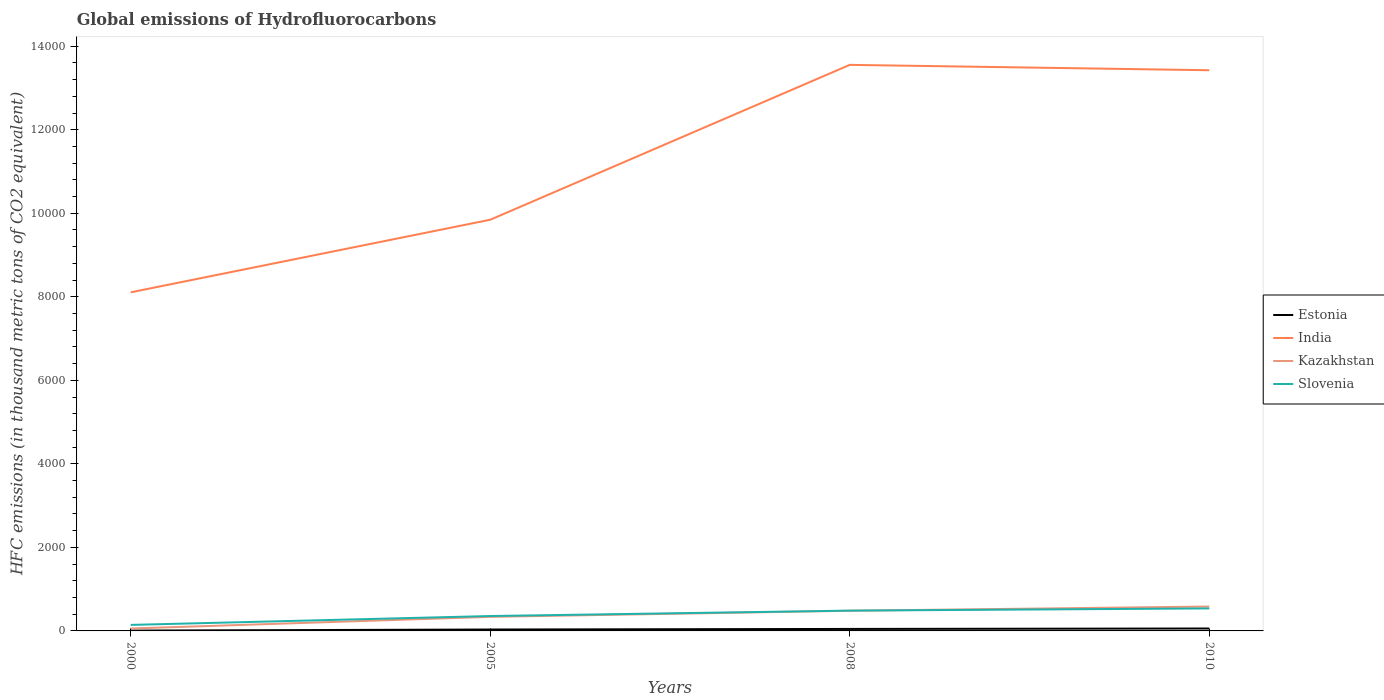How many different coloured lines are there?
Provide a succinct answer. 4. Is the number of lines equal to the number of legend labels?
Keep it short and to the point. Yes. Across all years, what is the maximum global emissions of Hydrofluorocarbons in Kazakhstan?
Keep it short and to the point. 57.5. What is the total global emissions of Hydrofluorocarbons in Kazakhstan in the graph?
Your answer should be very brief. -425.4. What is the difference between the highest and the second highest global emissions of Hydrofluorocarbons in Kazakhstan?
Make the answer very short. 526.5. Is the global emissions of Hydrofluorocarbons in India strictly greater than the global emissions of Hydrofluorocarbons in Estonia over the years?
Offer a very short reply. No. How many lines are there?
Offer a very short reply. 4. What is the difference between two consecutive major ticks on the Y-axis?
Your response must be concise. 2000. Where does the legend appear in the graph?
Give a very brief answer. Center right. How many legend labels are there?
Give a very brief answer. 4. How are the legend labels stacked?
Your answer should be very brief. Vertical. What is the title of the graph?
Keep it short and to the point. Global emissions of Hydrofluorocarbons. What is the label or title of the X-axis?
Your answer should be very brief. Years. What is the label or title of the Y-axis?
Offer a very short reply. HFC emissions (in thousand metric tons of CO2 equivalent). What is the HFC emissions (in thousand metric tons of CO2 equivalent) in India in 2000?
Make the answer very short. 8107.2. What is the HFC emissions (in thousand metric tons of CO2 equivalent) of Kazakhstan in 2000?
Make the answer very short. 57.5. What is the HFC emissions (in thousand metric tons of CO2 equivalent) in Slovenia in 2000?
Keep it short and to the point. 144.1. What is the HFC emissions (in thousand metric tons of CO2 equivalent) in Estonia in 2005?
Make the answer very short. 33.8. What is the HFC emissions (in thousand metric tons of CO2 equivalent) of India in 2005?
Provide a succinct answer. 9845.2. What is the HFC emissions (in thousand metric tons of CO2 equivalent) of Kazakhstan in 2005?
Your answer should be very brief. 336.7. What is the HFC emissions (in thousand metric tons of CO2 equivalent) of Slovenia in 2005?
Keep it short and to the point. 356.4. What is the HFC emissions (in thousand metric tons of CO2 equivalent) of Estonia in 2008?
Make the answer very short. 47.6. What is the HFC emissions (in thousand metric tons of CO2 equivalent) in India in 2008?
Your answer should be very brief. 1.36e+04. What is the HFC emissions (in thousand metric tons of CO2 equivalent) of Kazakhstan in 2008?
Provide a succinct answer. 482.9. What is the HFC emissions (in thousand metric tons of CO2 equivalent) of Slovenia in 2008?
Offer a very short reply. 486. What is the HFC emissions (in thousand metric tons of CO2 equivalent) of India in 2010?
Ensure brevity in your answer.  1.34e+04. What is the HFC emissions (in thousand metric tons of CO2 equivalent) in Kazakhstan in 2010?
Offer a terse response. 584. What is the HFC emissions (in thousand metric tons of CO2 equivalent) of Slovenia in 2010?
Provide a short and direct response. 539. Across all years, what is the maximum HFC emissions (in thousand metric tons of CO2 equivalent) of Estonia?
Offer a terse response. 58. Across all years, what is the maximum HFC emissions (in thousand metric tons of CO2 equivalent) in India?
Keep it short and to the point. 1.36e+04. Across all years, what is the maximum HFC emissions (in thousand metric tons of CO2 equivalent) of Kazakhstan?
Offer a very short reply. 584. Across all years, what is the maximum HFC emissions (in thousand metric tons of CO2 equivalent) of Slovenia?
Your answer should be compact. 539. Across all years, what is the minimum HFC emissions (in thousand metric tons of CO2 equivalent) in India?
Keep it short and to the point. 8107.2. Across all years, what is the minimum HFC emissions (in thousand metric tons of CO2 equivalent) in Kazakhstan?
Your answer should be compact. 57.5. Across all years, what is the minimum HFC emissions (in thousand metric tons of CO2 equivalent) of Slovenia?
Your answer should be compact. 144.1. What is the total HFC emissions (in thousand metric tons of CO2 equivalent) in Estonia in the graph?
Offer a very short reply. 147.2. What is the total HFC emissions (in thousand metric tons of CO2 equivalent) in India in the graph?
Keep it short and to the point. 4.49e+04. What is the total HFC emissions (in thousand metric tons of CO2 equivalent) of Kazakhstan in the graph?
Make the answer very short. 1461.1. What is the total HFC emissions (in thousand metric tons of CO2 equivalent) of Slovenia in the graph?
Your answer should be compact. 1525.5. What is the difference between the HFC emissions (in thousand metric tons of CO2 equivalent) of India in 2000 and that in 2005?
Give a very brief answer. -1738. What is the difference between the HFC emissions (in thousand metric tons of CO2 equivalent) in Kazakhstan in 2000 and that in 2005?
Offer a very short reply. -279.2. What is the difference between the HFC emissions (in thousand metric tons of CO2 equivalent) of Slovenia in 2000 and that in 2005?
Ensure brevity in your answer.  -212.3. What is the difference between the HFC emissions (in thousand metric tons of CO2 equivalent) in Estonia in 2000 and that in 2008?
Your answer should be compact. -39.8. What is the difference between the HFC emissions (in thousand metric tons of CO2 equivalent) of India in 2000 and that in 2008?
Make the answer very short. -5446.5. What is the difference between the HFC emissions (in thousand metric tons of CO2 equivalent) of Kazakhstan in 2000 and that in 2008?
Your response must be concise. -425.4. What is the difference between the HFC emissions (in thousand metric tons of CO2 equivalent) in Slovenia in 2000 and that in 2008?
Ensure brevity in your answer.  -341.9. What is the difference between the HFC emissions (in thousand metric tons of CO2 equivalent) of Estonia in 2000 and that in 2010?
Make the answer very short. -50.2. What is the difference between the HFC emissions (in thousand metric tons of CO2 equivalent) of India in 2000 and that in 2010?
Ensure brevity in your answer.  -5317.8. What is the difference between the HFC emissions (in thousand metric tons of CO2 equivalent) in Kazakhstan in 2000 and that in 2010?
Offer a terse response. -526.5. What is the difference between the HFC emissions (in thousand metric tons of CO2 equivalent) of Slovenia in 2000 and that in 2010?
Offer a terse response. -394.9. What is the difference between the HFC emissions (in thousand metric tons of CO2 equivalent) in India in 2005 and that in 2008?
Offer a terse response. -3708.5. What is the difference between the HFC emissions (in thousand metric tons of CO2 equivalent) in Kazakhstan in 2005 and that in 2008?
Provide a short and direct response. -146.2. What is the difference between the HFC emissions (in thousand metric tons of CO2 equivalent) in Slovenia in 2005 and that in 2008?
Give a very brief answer. -129.6. What is the difference between the HFC emissions (in thousand metric tons of CO2 equivalent) in Estonia in 2005 and that in 2010?
Offer a terse response. -24.2. What is the difference between the HFC emissions (in thousand metric tons of CO2 equivalent) in India in 2005 and that in 2010?
Make the answer very short. -3579.8. What is the difference between the HFC emissions (in thousand metric tons of CO2 equivalent) of Kazakhstan in 2005 and that in 2010?
Ensure brevity in your answer.  -247.3. What is the difference between the HFC emissions (in thousand metric tons of CO2 equivalent) of Slovenia in 2005 and that in 2010?
Provide a short and direct response. -182.6. What is the difference between the HFC emissions (in thousand metric tons of CO2 equivalent) of India in 2008 and that in 2010?
Provide a succinct answer. 128.7. What is the difference between the HFC emissions (in thousand metric tons of CO2 equivalent) in Kazakhstan in 2008 and that in 2010?
Ensure brevity in your answer.  -101.1. What is the difference between the HFC emissions (in thousand metric tons of CO2 equivalent) of Slovenia in 2008 and that in 2010?
Ensure brevity in your answer.  -53. What is the difference between the HFC emissions (in thousand metric tons of CO2 equivalent) of Estonia in 2000 and the HFC emissions (in thousand metric tons of CO2 equivalent) of India in 2005?
Ensure brevity in your answer.  -9837.4. What is the difference between the HFC emissions (in thousand metric tons of CO2 equivalent) of Estonia in 2000 and the HFC emissions (in thousand metric tons of CO2 equivalent) of Kazakhstan in 2005?
Ensure brevity in your answer.  -328.9. What is the difference between the HFC emissions (in thousand metric tons of CO2 equivalent) in Estonia in 2000 and the HFC emissions (in thousand metric tons of CO2 equivalent) in Slovenia in 2005?
Give a very brief answer. -348.6. What is the difference between the HFC emissions (in thousand metric tons of CO2 equivalent) of India in 2000 and the HFC emissions (in thousand metric tons of CO2 equivalent) of Kazakhstan in 2005?
Your response must be concise. 7770.5. What is the difference between the HFC emissions (in thousand metric tons of CO2 equivalent) of India in 2000 and the HFC emissions (in thousand metric tons of CO2 equivalent) of Slovenia in 2005?
Offer a very short reply. 7750.8. What is the difference between the HFC emissions (in thousand metric tons of CO2 equivalent) in Kazakhstan in 2000 and the HFC emissions (in thousand metric tons of CO2 equivalent) in Slovenia in 2005?
Give a very brief answer. -298.9. What is the difference between the HFC emissions (in thousand metric tons of CO2 equivalent) of Estonia in 2000 and the HFC emissions (in thousand metric tons of CO2 equivalent) of India in 2008?
Give a very brief answer. -1.35e+04. What is the difference between the HFC emissions (in thousand metric tons of CO2 equivalent) in Estonia in 2000 and the HFC emissions (in thousand metric tons of CO2 equivalent) in Kazakhstan in 2008?
Your answer should be compact. -475.1. What is the difference between the HFC emissions (in thousand metric tons of CO2 equivalent) of Estonia in 2000 and the HFC emissions (in thousand metric tons of CO2 equivalent) of Slovenia in 2008?
Your answer should be compact. -478.2. What is the difference between the HFC emissions (in thousand metric tons of CO2 equivalent) of India in 2000 and the HFC emissions (in thousand metric tons of CO2 equivalent) of Kazakhstan in 2008?
Provide a short and direct response. 7624.3. What is the difference between the HFC emissions (in thousand metric tons of CO2 equivalent) in India in 2000 and the HFC emissions (in thousand metric tons of CO2 equivalent) in Slovenia in 2008?
Keep it short and to the point. 7621.2. What is the difference between the HFC emissions (in thousand metric tons of CO2 equivalent) in Kazakhstan in 2000 and the HFC emissions (in thousand metric tons of CO2 equivalent) in Slovenia in 2008?
Offer a terse response. -428.5. What is the difference between the HFC emissions (in thousand metric tons of CO2 equivalent) in Estonia in 2000 and the HFC emissions (in thousand metric tons of CO2 equivalent) in India in 2010?
Your answer should be very brief. -1.34e+04. What is the difference between the HFC emissions (in thousand metric tons of CO2 equivalent) in Estonia in 2000 and the HFC emissions (in thousand metric tons of CO2 equivalent) in Kazakhstan in 2010?
Keep it short and to the point. -576.2. What is the difference between the HFC emissions (in thousand metric tons of CO2 equivalent) in Estonia in 2000 and the HFC emissions (in thousand metric tons of CO2 equivalent) in Slovenia in 2010?
Provide a succinct answer. -531.2. What is the difference between the HFC emissions (in thousand metric tons of CO2 equivalent) in India in 2000 and the HFC emissions (in thousand metric tons of CO2 equivalent) in Kazakhstan in 2010?
Your response must be concise. 7523.2. What is the difference between the HFC emissions (in thousand metric tons of CO2 equivalent) in India in 2000 and the HFC emissions (in thousand metric tons of CO2 equivalent) in Slovenia in 2010?
Ensure brevity in your answer.  7568.2. What is the difference between the HFC emissions (in thousand metric tons of CO2 equivalent) in Kazakhstan in 2000 and the HFC emissions (in thousand metric tons of CO2 equivalent) in Slovenia in 2010?
Your answer should be very brief. -481.5. What is the difference between the HFC emissions (in thousand metric tons of CO2 equivalent) in Estonia in 2005 and the HFC emissions (in thousand metric tons of CO2 equivalent) in India in 2008?
Your answer should be very brief. -1.35e+04. What is the difference between the HFC emissions (in thousand metric tons of CO2 equivalent) of Estonia in 2005 and the HFC emissions (in thousand metric tons of CO2 equivalent) of Kazakhstan in 2008?
Offer a very short reply. -449.1. What is the difference between the HFC emissions (in thousand metric tons of CO2 equivalent) in Estonia in 2005 and the HFC emissions (in thousand metric tons of CO2 equivalent) in Slovenia in 2008?
Your response must be concise. -452.2. What is the difference between the HFC emissions (in thousand metric tons of CO2 equivalent) in India in 2005 and the HFC emissions (in thousand metric tons of CO2 equivalent) in Kazakhstan in 2008?
Provide a succinct answer. 9362.3. What is the difference between the HFC emissions (in thousand metric tons of CO2 equivalent) in India in 2005 and the HFC emissions (in thousand metric tons of CO2 equivalent) in Slovenia in 2008?
Your answer should be compact. 9359.2. What is the difference between the HFC emissions (in thousand metric tons of CO2 equivalent) in Kazakhstan in 2005 and the HFC emissions (in thousand metric tons of CO2 equivalent) in Slovenia in 2008?
Offer a terse response. -149.3. What is the difference between the HFC emissions (in thousand metric tons of CO2 equivalent) in Estonia in 2005 and the HFC emissions (in thousand metric tons of CO2 equivalent) in India in 2010?
Your response must be concise. -1.34e+04. What is the difference between the HFC emissions (in thousand metric tons of CO2 equivalent) in Estonia in 2005 and the HFC emissions (in thousand metric tons of CO2 equivalent) in Kazakhstan in 2010?
Give a very brief answer. -550.2. What is the difference between the HFC emissions (in thousand metric tons of CO2 equivalent) in Estonia in 2005 and the HFC emissions (in thousand metric tons of CO2 equivalent) in Slovenia in 2010?
Give a very brief answer. -505.2. What is the difference between the HFC emissions (in thousand metric tons of CO2 equivalent) in India in 2005 and the HFC emissions (in thousand metric tons of CO2 equivalent) in Kazakhstan in 2010?
Give a very brief answer. 9261.2. What is the difference between the HFC emissions (in thousand metric tons of CO2 equivalent) in India in 2005 and the HFC emissions (in thousand metric tons of CO2 equivalent) in Slovenia in 2010?
Give a very brief answer. 9306.2. What is the difference between the HFC emissions (in thousand metric tons of CO2 equivalent) of Kazakhstan in 2005 and the HFC emissions (in thousand metric tons of CO2 equivalent) of Slovenia in 2010?
Make the answer very short. -202.3. What is the difference between the HFC emissions (in thousand metric tons of CO2 equivalent) in Estonia in 2008 and the HFC emissions (in thousand metric tons of CO2 equivalent) in India in 2010?
Keep it short and to the point. -1.34e+04. What is the difference between the HFC emissions (in thousand metric tons of CO2 equivalent) of Estonia in 2008 and the HFC emissions (in thousand metric tons of CO2 equivalent) of Kazakhstan in 2010?
Your answer should be very brief. -536.4. What is the difference between the HFC emissions (in thousand metric tons of CO2 equivalent) of Estonia in 2008 and the HFC emissions (in thousand metric tons of CO2 equivalent) of Slovenia in 2010?
Ensure brevity in your answer.  -491.4. What is the difference between the HFC emissions (in thousand metric tons of CO2 equivalent) of India in 2008 and the HFC emissions (in thousand metric tons of CO2 equivalent) of Kazakhstan in 2010?
Your response must be concise. 1.30e+04. What is the difference between the HFC emissions (in thousand metric tons of CO2 equivalent) of India in 2008 and the HFC emissions (in thousand metric tons of CO2 equivalent) of Slovenia in 2010?
Provide a short and direct response. 1.30e+04. What is the difference between the HFC emissions (in thousand metric tons of CO2 equivalent) of Kazakhstan in 2008 and the HFC emissions (in thousand metric tons of CO2 equivalent) of Slovenia in 2010?
Provide a succinct answer. -56.1. What is the average HFC emissions (in thousand metric tons of CO2 equivalent) in Estonia per year?
Make the answer very short. 36.8. What is the average HFC emissions (in thousand metric tons of CO2 equivalent) of India per year?
Ensure brevity in your answer.  1.12e+04. What is the average HFC emissions (in thousand metric tons of CO2 equivalent) in Kazakhstan per year?
Offer a terse response. 365.27. What is the average HFC emissions (in thousand metric tons of CO2 equivalent) of Slovenia per year?
Your answer should be very brief. 381.38. In the year 2000, what is the difference between the HFC emissions (in thousand metric tons of CO2 equivalent) of Estonia and HFC emissions (in thousand metric tons of CO2 equivalent) of India?
Keep it short and to the point. -8099.4. In the year 2000, what is the difference between the HFC emissions (in thousand metric tons of CO2 equivalent) of Estonia and HFC emissions (in thousand metric tons of CO2 equivalent) of Kazakhstan?
Ensure brevity in your answer.  -49.7. In the year 2000, what is the difference between the HFC emissions (in thousand metric tons of CO2 equivalent) of Estonia and HFC emissions (in thousand metric tons of CO2 equivalent) of Slovenia?
Provide a short and direct response. -136.3. In the year 2000, what is the difference between the HFC emissions (in thousand metric tons of CO2 equivalent) in India and HFC emissions (in thousand metric tons of CO2 equivalent) in Kazakhstan?
Offer a very short reply. 8049.7. In the year 2000, what is the difference between the HFC emissions (in thousand metric tons of CO2 equivalent) of India and HFC emissions (in thousand metric tons of CO2 equivalent) of Slovenia?
Give a very brief answer. 7963.1. In the year 2000, what is the difference between the HFC emissions (in thousand metric tons of CO2 equivalent) of Kazakhstan and HFC emissions (in thousand metric tons of CO2 equivalent) of Slovenia?
Your answer should be very brief. -86.6. In the year 2005, what is the difference between the HFC emissions (in thousand metric tons of CO2 equivalent) of Estonia and HFC emissions (in thousand metric tons of CO2 equivalent) of India?
Ensure brevity in your answer.  -9811.4. In the year 2005, what is the difference between the HFC emissions (in thousand metric tons of CO2 equivalent) of Estonia and HFC emissions (in thousand metric tons of CO2 equivalent) of Kazakhstan?
Offer a very short reply. -302.9. In the year 2005, what is the difference between the HFC emissions (in thousand metric tons of CO2 equivalent) of Estonia and HFC emissions (in thousand metric tons of CO2 equivalent) of Slovenia?
Your answer should be very brief. -322.6. In the year 2005, what is the difference between the HFC emissions (in thousand metric tons of CO2 equivalent) of India and HFC emissions (in thousand metric tons of CO2 equivalent) of Kazakhstan?
Ensure brevity in your answer.  9508.5. In the year 2005, what is the difference between the HFC emissions (in thousand metric tons of CO2 equivalent) of India and HFC emissions (in thousand metric tons of CO2 equivalent) of Slovenia?
Your response must be concise. 9488.8. In the year 2005, what is the difference between the HFC emissions (in thousand metric tons of CO2 equivalent) in Kazakhstan and HFC emissions (in thousand metric tons of CO2 equivalent) in Slovenia?
Your answer should be compact. -19.7. In the year 2008, what is the difference between the HFC emissions (in thousand metric tons of CO2 equivalent) of Estonia and HFC emissions (in thousand metric tons of CO2 equivalent) of India?
Your response must be concise. -1.35e+04. In the year 2008, what is the difference between the HFC emissions (in thousand metric tons of CO2 equivalent) of Estonia and HFC emissions (in thousand metric tons of CO2 equivalent) of Kazakhstan?
Make the answer very short. -435.3. In the year 2008, what is the difference between the HFC emissions (in thousand metric tons of CO2 equivalent) in Estonia and HFC emissions (in thousand metric tons of CO2 equivalent) in Slovenia?
Your response must be concise. -438.4. In the year 2008, what is the difference between the HFC emissions (in thousand metric tons of CO2 equivalent) of India and HFC emissions (in thousand metric tons of CO2 equivalent) of Kazakhstan?
Your answer should be very brief. 1.31e+04. In the year 2008, what is the difference between the HFC emissions (in thousand metric tons of CO2 equivalent) in India and HFC emissions (in thousand metric tons of CO2 equivalent) in Slovenia?
Give a very brief answer. 1.31e+04. In the year 2008, what is the difference between the HFC emissions (in thousand metric tons of CO2 equivalent) of Kazakhstan and HFC emissions (in thousand metric tons of CO2 equivalent) of Slovenia?
Offer a very short reply. -3.1. In the year 2010, what is the difference between the HFC emissions (in thousand metric tons of CO2 equivalent) in Estonia and HFC emissions (in thousand metric tons of CO2 equivalent) in India?
Your answer should be compact. -1.34e+04. In the year 2010, what is the difference between the HFC emissions (in thousand metric tons of CO2 equivalent) in Estonia and HFC emissions (in thousand metric tons of CO2 equivalent) in Kazakhstan?
Give a very brief answer. -526. In the year 2010, what is the difference between the HFC emissions (in thousand metric tons of CO2 equivalent) in Estonia and HFC emissions (in thousand metric tons of CO2 equivalent) in Slovenia?
Offer a terse response. -481. In the year 2010, what is the difference between the HFC emissions (in thousand metric tons of CO2 equivalent) in India and HFC emissions (in thousand metric tons of CO2 equivalent) in Kazakhstan?
Make the answer very short. 1.28e+04. In the year 2010, what is the difference between the HFC emissions (in thousand metric tons of CO2 equivalent) of India and HFC emissions (in thousand metric tons of CO2 equivalent) of Slovenia?
Give a very brief answer. 1.29e+04. In the year 2010, what is the difference between the HFC emissions (in thousand metric tons of CO2 equivalent) of Kazakhstan and HFC emissions (in thousand metric tons of CO2 equivalent) of Slovenia?
Make the answer very short. 45. What is the ratio of the HFC emissions (in thousand metric tons of CO2 equivalent) in Estonia in 2000 to that in 2005?
Provide a succinct answer. 0.23. What is the ratio of the HFC emissions (in thousand metric tons of CO2 equivalent) of India in 2000 to that in 2005?
Your answer should be very brief. 0.82. What is the ratio of the HFC emissions (in thousand metric tons of CO2 equivalent) in Kazakhstan in 2000 to that in 2005?
Provide a short and direct response. 0.17. What is the ratio of the HFC emissions (in thousand metric tons of CO2 equivalent) in Slovenia in 2000 to that in 2005?
Your answer should be very brief. 0.4. What is the ratio of the HFC emissions (in thousand metric tons of CO2 equivalent) in Estonia in 2000 to that in 2008?
Offer a very short reply. 0.16. What is the ratio of the HFC emissions (in thousand metric tons of CO2 equivalent) of India in 2000 to that in 2008?
Offer a terse response. 0.6. What is the ratio of the HFC emissions (in thousand metric tons of CO2 equivalent) of Kazakhstan in 2000 to that in 2008?
Make the answer very short. 0.12. What is the ratio of the HFC emissions (in thousand metric tons of CO2 equivalent) in Slovenia in 2000 to that in 2008?
Provide a succinct answer. 0.3. What is the ratio of the HFC emissions (in thousand metric tons of CO2 equivalent) in Estonia in 2000 to that in 2010?
Your answer should be very brief. 0.13. What is the ratio of the HFC emissions (in thousand metric tons of CO2 equivalent) of India in 2000 to that in 2010?
Give a very brief answer. 0.6. What is the ratio of the HFC emissions (in thousand metric tons of CO2 equivalent) of Kazakhstan in 2000 to that in 2010?
Give a very brief answer. 0.1. What is the ratio of the HFC emissions (in thousand metric tons of CO2 equivalent) in Slovenia in 2000 to that in 2010?
Your answer should be very brief. 0.27. What is the ratio of the HFC emissions (in thousand metric tons of CO2 equivalent) of Estonia in 2005 to that in 2008?
Offer a very short reply. 0.71. What is the ratio of the HFC emissions (in thousand metric tons of CO2 equivalent) of India in 2005 to that in 2008?
Make the answer very short. 0.73. What is the ratio of the HFC emissions (in thousand metric tons of CO2 equivalent) of Kazakhstan in 2005 to that in 2008?
Offer a very short reply. 0.7. What is the ratio of the HFC emissions (in thousand metric tons of CO2 equivalent) of Slovenia in 2005 to that in 2008?
Ensure brevity in your answer.  0.73. What is the ratio of the HFC emissions (in thousand metric tons of CO2 equivalent) in Estonia in 2005 to that in 2010?
Offer a very short reply. 0.58. What is the ratio of the HFC emissions (in thousand metric tons of CO2 equivalent) of India in 2005 to that in 2010?
Keep it short and to the point. 0.73. What is the ratio of the HFC emissions (in thousand metric tons of CO2 equivalent) of Kazakhstan in 2005 to that in 2010?
Make the answer very short. 0.58. What is the ratio of the HFC emissions (in thousand metric tons of CO2 equivalent) in Slovenia in 2005 to that in 2010?
Your answer should be very brief. 0.66. What is the ratio of the HFC emissions (in thousand metric tons of CO2 equivalent) in Estonia in 2008 to that in 2010?
Offer a terse response. 0.82. What is the ratio of the HFC emissions (in thousand metric tons of CO2 equivalent) of India in 2008 to that in 2010?
Your answer should be compact. 1.01. What is the ratio of the HFC emissions (in thousand metric tons of CO2 equivalent) of Kazakhstan in 2008 to that in 2010?
Your answer should be compact. 0.83. What is the ratio of the HFC emissions (in thousand metric tons of CO2 equivalent) of Slovenia in 2008 to that in 2010?
Give a very brief answer. 0.9. What is the difference between the highest and the second highest HFC emissions (in thousand metric tons of CO2 equivalent) in Estonia?
Offer a terse response. 10.4. What is the difference between the highest and the second highest HFC emissions (in thousand metric tons of CO2 equivalent) in India?
Offer a very short reply. 128.7. What is the difference between the highest and the second highest HFC emissions (in thousand metric tons of CO2 equivalent) in Kazakhstan?
Offer a terse response. 101.1. What is the difference between the highest and the second highest HFC emissions (in thousand metric tons of CO2 equivalent) in Slovenia?
Offer a terse response. 53. What is the difference between the highest and the lowest HFC emissions (in thousand metric tons of CO2 equivalent) in Estonia?
Provide a succinct answer. 50.2. What is the difference between the highest and the lowest HFC emissions (in thousand metric tons of CO2 equivalent) of India?
Ensure brevity in your answer.  5446.5. What is the difference between the highest and the lowest HFC emissions (in thousand metric tons of CO2 equivalent) in Kazakhstan?
Make the answer very short. 526.5. What is the difference between the highest and the lowest HFC emissions (in thousand metric tons of CO2 equivalent) of Slovenia?
Your response must be concise. 394.9. 